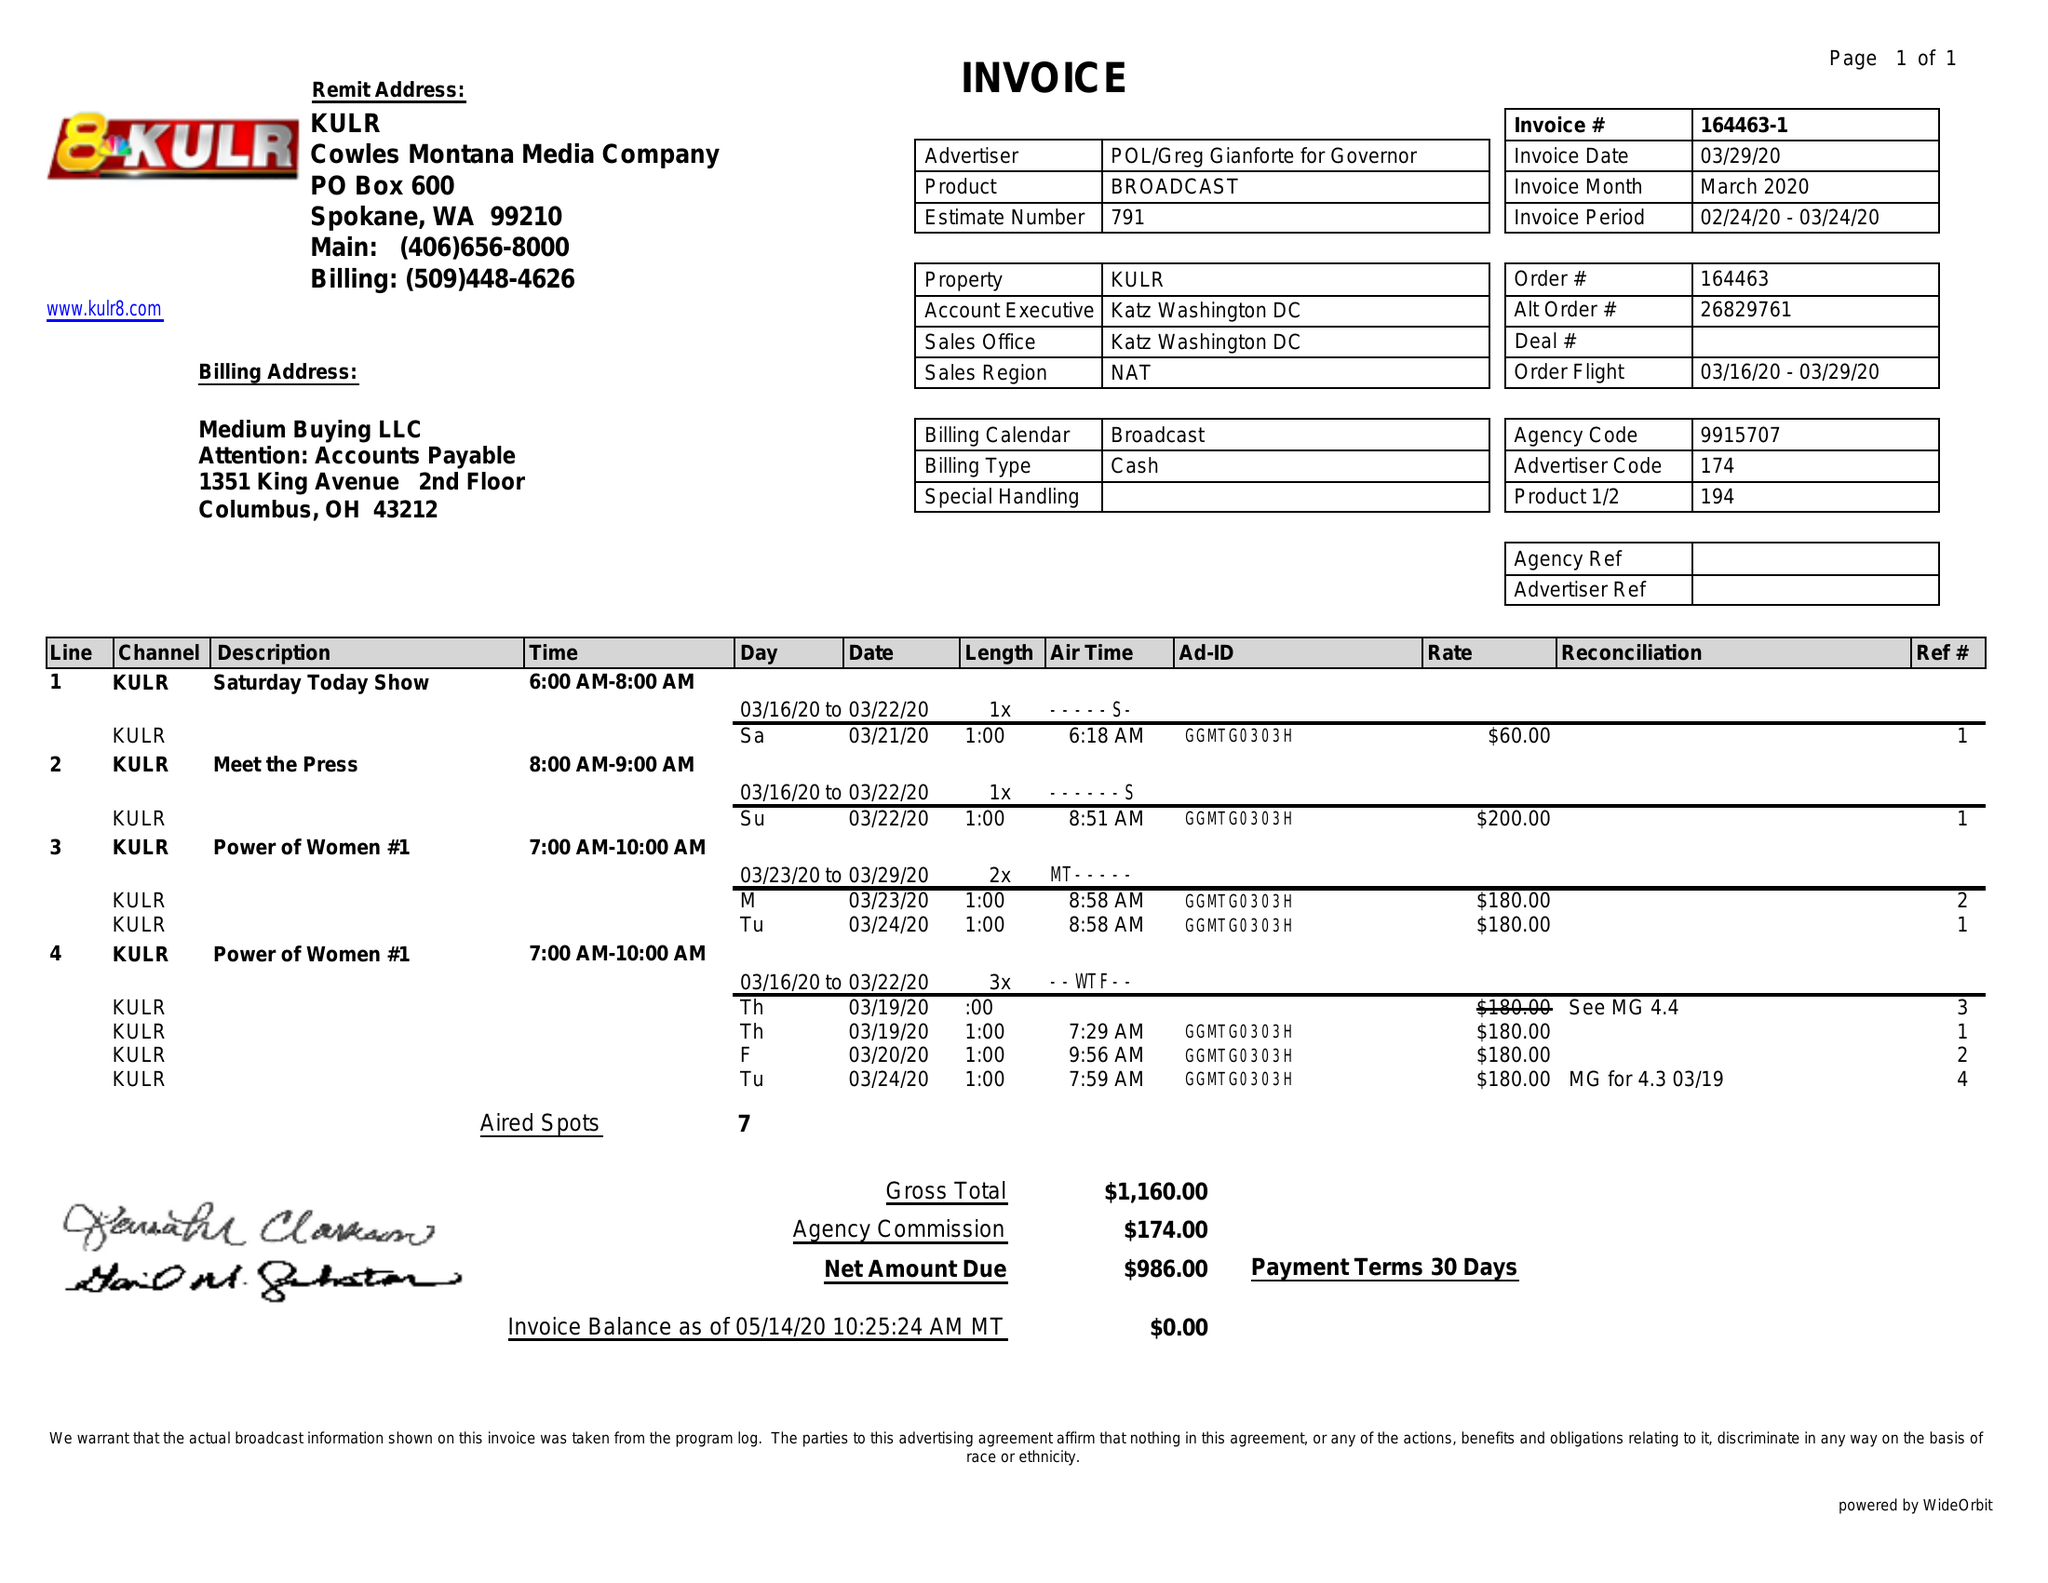What is the value for the flight_to?
Answer the question using a single word or phrase. 03/24/20 